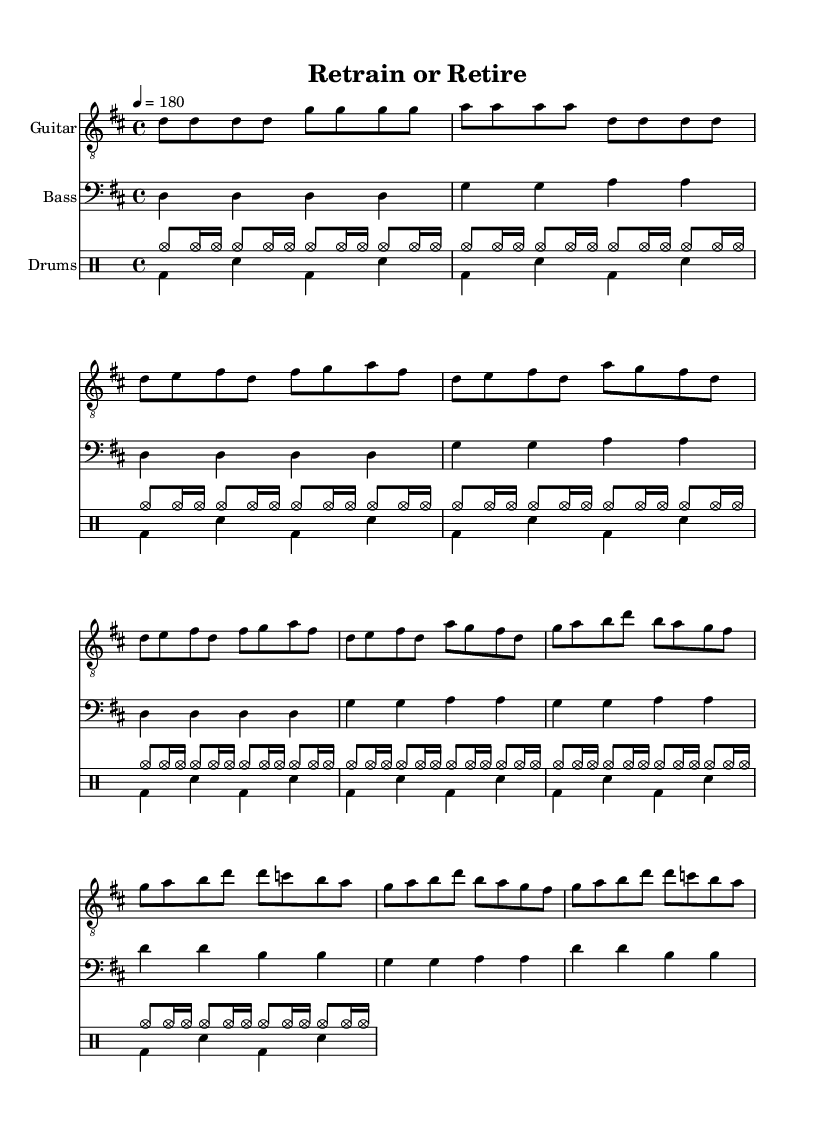What is the key signature of this music? The key signature is indicated at the beginning of the sheet music, showing two sharps (F# and C#), which places the key in D major.
Answer: D major What is the time signature of the piece? The time signature is displayed at the start of the music, showing a 4 over 4, indicating that there are four beats in each measure.
Answer: 4/4 What is the tempo marking for this music? The tempo marking at the beginning states "4 = 180", which means there are 180 beats per minute, indicating a fast pace.
Answer: 180 How many measures are there in the Chorus section? By counting the measures in the Chorus section as notated in the sheet music, there are a total of 8 measures for the Chorus.
Answer: 8 What are the first two notes of the guitar part? The first two notes in the guitar part are both D notes, as seen in the introductory section of the sheet music.
Answer: D, D How is the theme of retraining reflected in the lyrics? The lyrics reveal the struggle of dealing with job displacement and the need to gain new skills, as highlighted in phrases like "Re-train or re-tire" and "New skills to acquire." This emphasizes the theme of career transition.
Answer: New skills to acquire What instrument plays the rhythm section in this arrangement? The rhythm section is provided by the drums, which enhance the driving beat characteristic of punk music.
Answer: Drums 